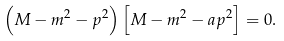<formula> <loc_0><loc_0><loc_500><loc_500>\left ( M - m ^ { 2 } - p ^ { 2 } \right ) \left [ M - m ^ { 2 } - a p ^ { 2 } \right ] = 0 .</formula> 